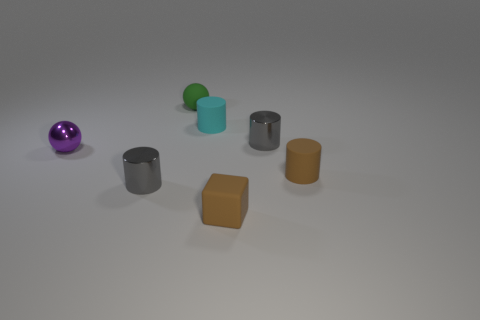Is there a cylinder of the same color as the matte cube?
Ensure brevity in your answer.  Yes. Does the cube have the same color as the small matte cylinder right of the tiny brown block?
Your answer should be very brief. Yes. There is a metallic cylinder in front of the gray shiny cylinder that is right of the rubber cube; how many tiny things are in front of it?
Make the answer very short. 1. Does the small gray metallic thing in front of the tiny purple ball have the same shape as the small cyan matte object?
Make the answer very short. Yes. There is a cyan cylinder that is on the right side of the tiny matte ball; what is it made of?
Offer a very short reply. Rubber. The matte thing that is on the left side of the brown cube and in front of the rubber sphere has what shape?
Keep it short and to the point. Cylinder. What is the tiny cyan cylinder made of?
Ensure brevity in your answer.  Rubber. How many spheres are small red metallic objects or purple objects?
Give a very brief answer. 1. Are the small cyan cylinder and the small purple thing made of the same material?
Offer a terse response. No. What is the material of the small thing that is both on the left side of the cyan matte object and behind the purple shiny ball?
Give a very brief answer. Rubber. 